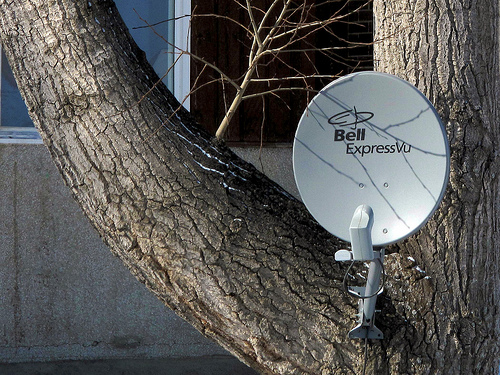<image>
Can you confirm if the antenna is on the tree? Yes. Looking at the image, I can see the antenna is positioned on top of the tree, with the tree providing support. Where is the dish in relation to the tree? Is it on the tree? Yes. Looking at the image, I can see the dish is positioned on top of the tree, with the tree providing support. 